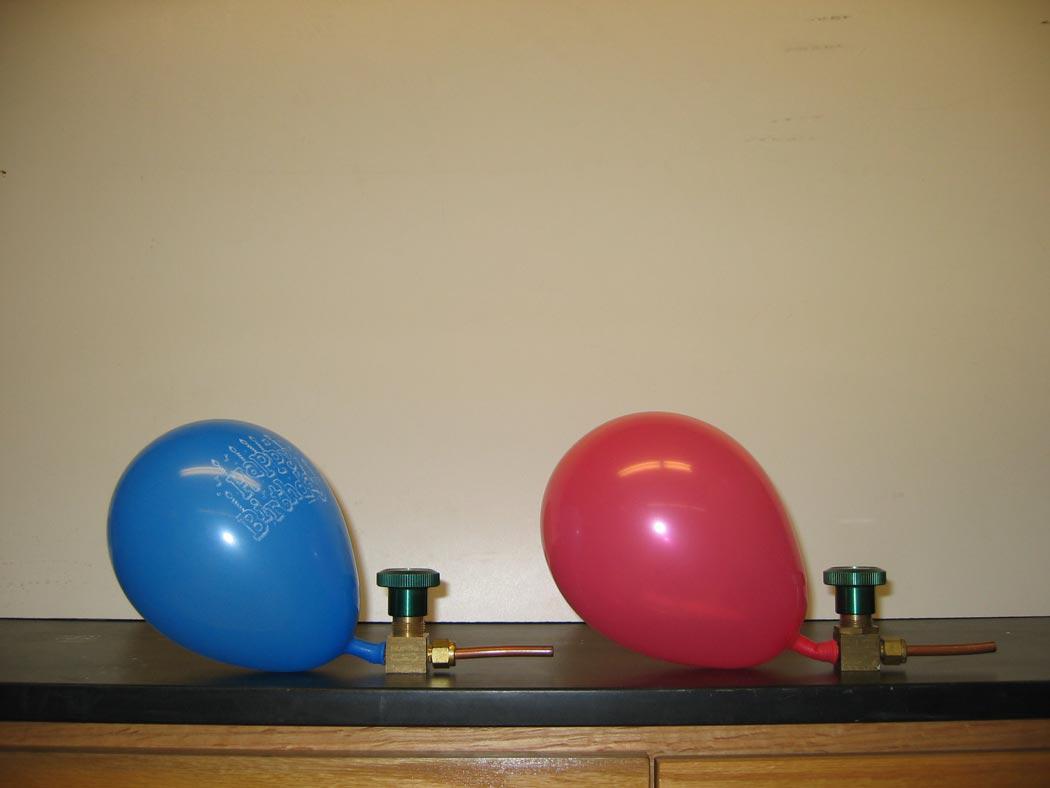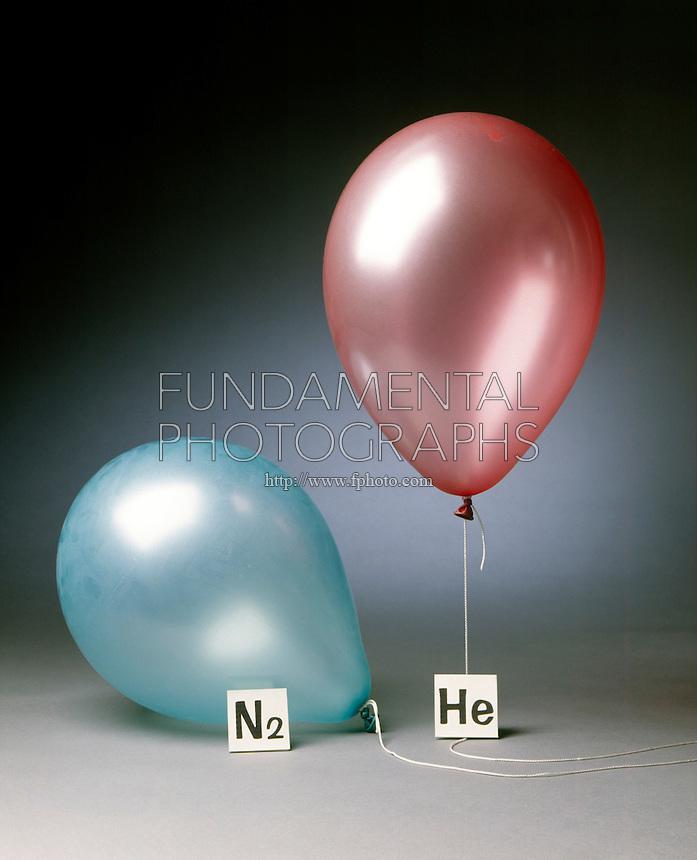The first image is the image on the left, the second image is the image on the right. Evaluate the accuracy of this statement regarding the images: "There are more balloons in the image on the right.". Is it true? Answer yes or no. No. The first image is the image on the left, the second image is the image on the right. Analyze the images presented: Is the assertion "A total of three balloons are shown, and one image contains only a pink-colored balloon." valid? Answer yes or no. No. 